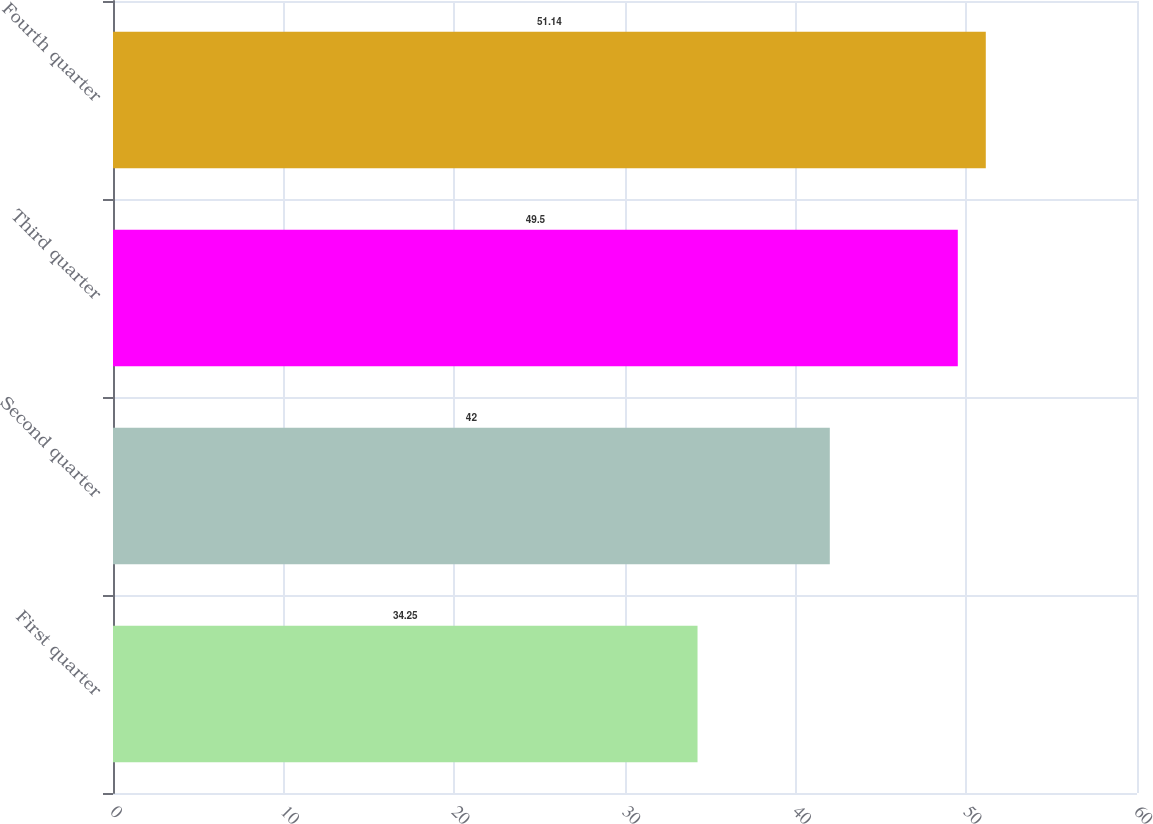Convert chart. <chart><loc_0><loc_0><loc_500><loc_500><bar_chart><fcel>First quarter<fcel>Second quarter<fcel>Third quarter<fcel>Fourth quarter<nl><fcel>34.25<fcel>42<fcel>49.5<fcel>51.14<nl></chart> 